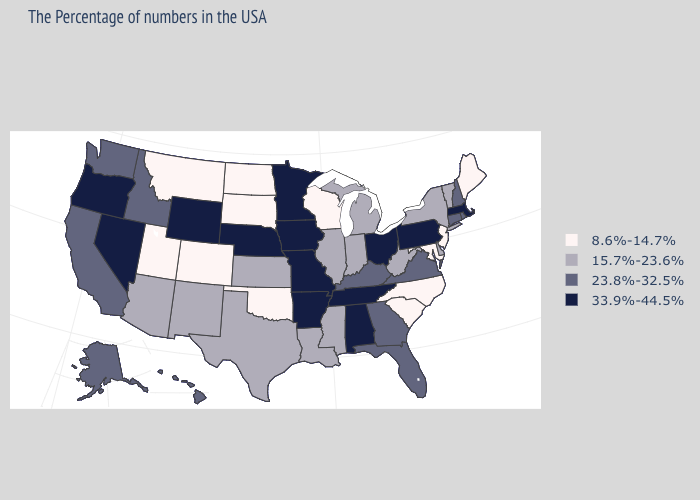Among the states that border Missouri , does Iowa have the highest value?
Quick response, please. Yes. What is the highest value in the USA?
Be succinct. 33.9%-44.5%. What is the value of Minnesota?
Write a very short answer. 33.9%-44.5%. Does North Dakota have the lowest value in the USA?
Short answer required. Yes. What is the value of Wisconsin?
Concise answer only. 8.6%-14.7%. Which states have the lowest value in the USA?
Keep it brief. Maine, New Jersey, Maryland, North Carolina, South Carolina, Wisconsin, Oklahoma, South Dakota, North Dakota, Colorado, Utah, Montana. What is the lowest value in the USA?
Be succinct. 8.6%-14.7%. What is the value of Arkansas?
Write a very short answer. 33.9%-44.5%. What is the highest value in the USA?
Quick response, please. 33.9%-44.5%. Among the states that border Iowa , which have the lowest value?
Be succinct. Wisconsin, South Dakota. What is the highest value in states that border New Hampshire?
Concise answer only. 33.9%-44.5%. What is the value of New Hampshire?
Give a very brief answer. 23.8%-32.5%. Which states have the lowest value in the MidWest?
Be succinct. Wisconsin, South Dakota, North Dakota. Which states have the lowest value in the Northeast?
Answer briefly. Maine, New Jersey. 